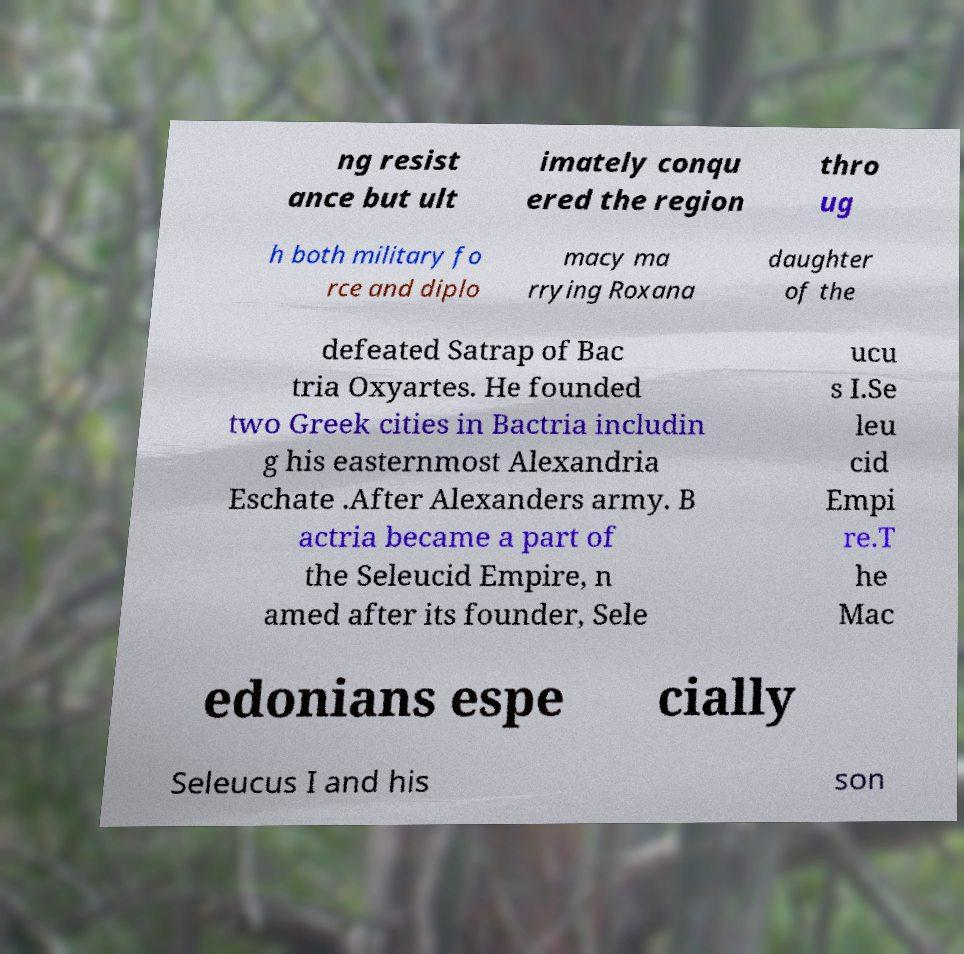What messages or text are displayed in this image? I need them in a readable, typed format. ng resist ance but ult imately conqu ered the region thro ug h both military fo rce and diplo macy ma rrying Roxana daughter of the defeated Satrap of Bac tria Oxyartes. He founded two Greek cities in Bactria includin g his easternmost Alexandria Eschate .After Alexanders army. B actria became a part of the Seleucid Empire, n amed after its founder, Sele ucu s I.Se leu cid Empi re.T he Mac edonians espe cially Seleucus I and his son 